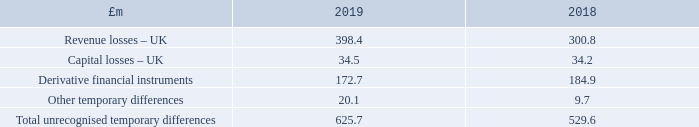10 Taxation (continued)
There are unrecognised deferred tax assets on the following temporary differences (presented below before the application of the relevant tax rate) due to uncertainty over the level of profits in the non-REIT elements of the Group in future periods:
The Company recognises no deferred tax asset or liability (2018: nil).
What is the revenue losses in UK in 2019?
Answer scale should be: million. 398.4. What is the value of Derivative financial instruments in 2019?
Answer scale should be: million. 172.7. What is the amount of capital losses in UK in 2019?
Answer scale should be: million. 34.5. What is the percentage change in the revenue losses in UK from 2018 to 2019?
Answer scale should be: percent. (398.4-300.8)/300.8
Answer: 32.45. What is the change in capital losses from the UK between 2018 and 2019?
Answer scale should be: million. 34.5-34.2
Answer: 0.3. What is the percentage change in the total unrecognised temporary differences from 2018 to 2019?
Answer scale should be: percent. (625.7-529.6)/529.6
Answer: 18.15. 